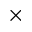Convert formula to latex. <formula><loc_0><loc_0><loc_500><loc_500>\times</formula> 